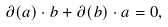<formula> <loc_0><loc_0><loc_500><loc_500>\partial ( a ) \cdot b + \partial ( b ) \cdot a = 0 ,</formula> 